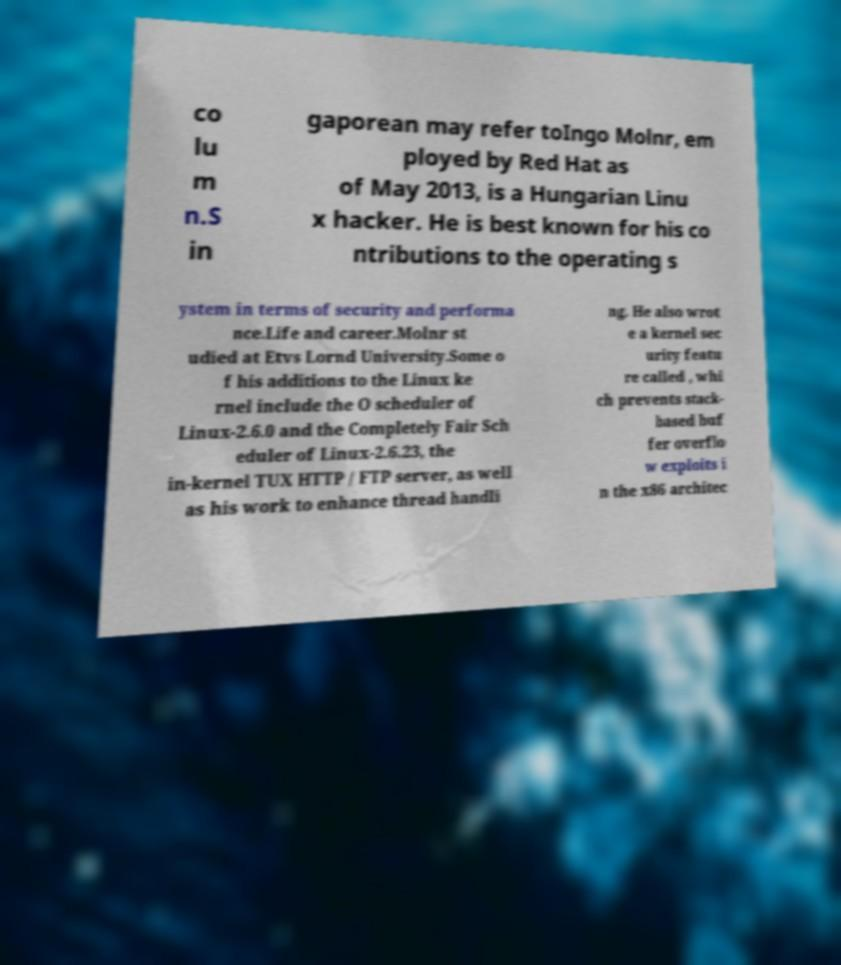What messages or text are displayed in this image? I need them in a readable, typed format. co lu m n.S in gaporean may refer toIngo Molnr, em ployed by Red Hat as of May 2013, is a Hungarian Linu x hacker. He is best known for his co ntributions to the operating s ystem in terms of security and performa nce.Life and career.Molnr st udied at Etvs Lornd University.Some o f his additions to the Linux ke rnel include the O scheduler of Linux-2.6.0 and the Completely Fair Sch eduler of Linux-2.6.23, the in-kernel TUX HTTP / FTP server, as well as his work to enhance thread handli ng. He also wrot e a kernel sec urity featu re called , whi ch prevents stack- based buf fer overflo w exploits i n the x86 architec 